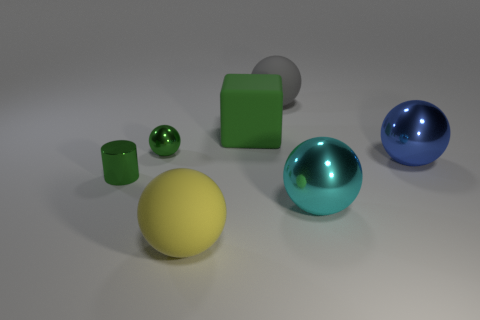Subtract 3 spheres. How many spheres are left? 2 Subtract all gray spheres. How many spheres are left? 4 Subtract all green spheres. How many spheres are left? 4 Subtract all purple balls. Subtract all yellow blocks. How many balls are left? 5 Add 3 large blue objects. How many objects exist? 10 Subtract all cylinders. How many objects are left? 6 Subtract all yellow metallic cylinders. Subtract all big yellow things. How many objects are left? 6 Add 7 big yellow rubber things. How many big yellow rubber things are left? 8 Add 2 red cubes. How many red cubes exist? 2 Subtract 0 red cubes. How many objects are left? 7 